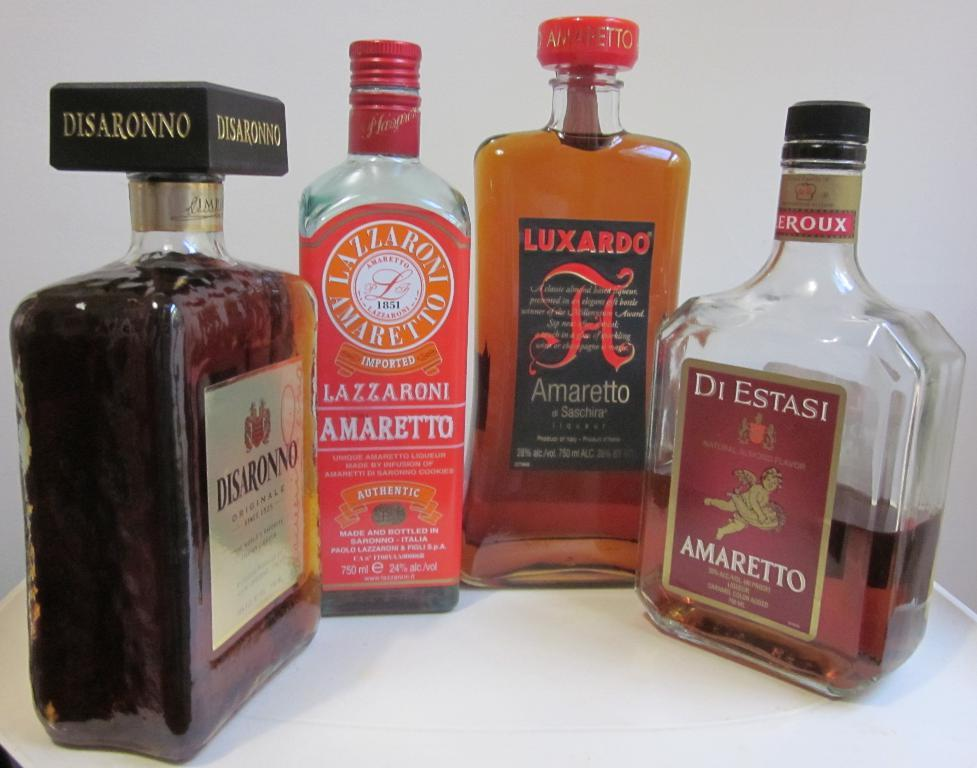<image>
Provide a brief description of the given image. Four bottles of booze, the right most bottle is a amaretto. 